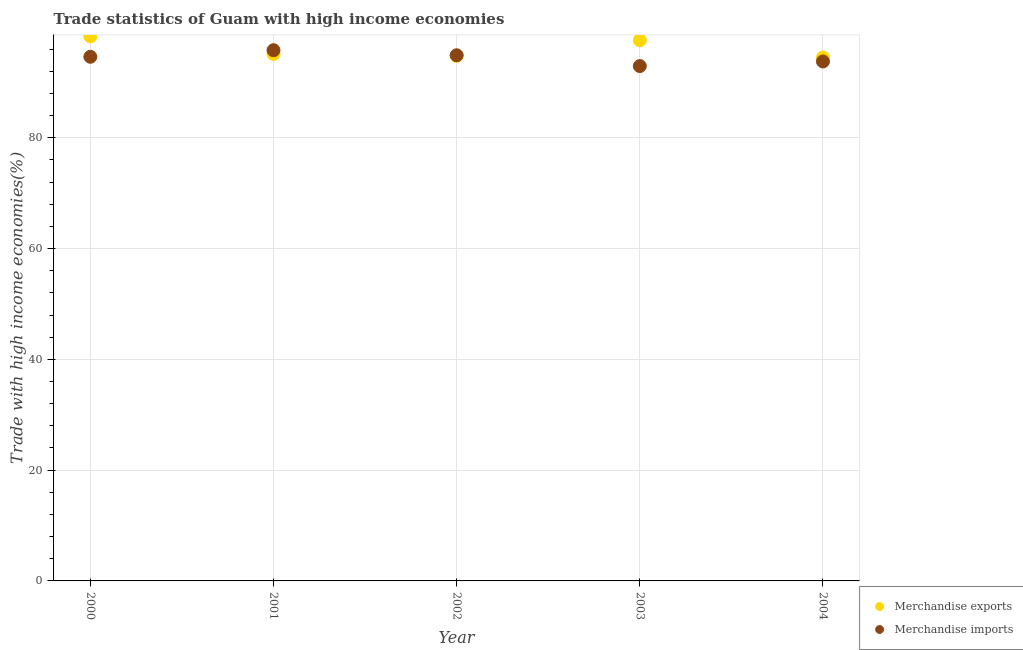How many different coloured dotlines are there?
Keep it short and to the point. 2. What is the merchandise imports in 2002?
Your response must be concise. 94.9. Across all years, what is the maximum merchandise imports?
Offer a terse response. 95.81. Across all years, what is the minimum merchandise exports?
Provide a succinct answer. 94.47. In which year was the merchandise exports maximum?
Offer a terse response. 2000. What is the total merchandise imports in the graph?
Your response must be concise. 472.04. What is the difference between the merchandise exports in 2000 and that in 2002?
Offer a terse response. 3.52. What is the difference between the merchandise exports in 2003 and the merchandise imports in 2001?
Give a very brief answer. 1.79. What is the average merchandise imports per year?
Provide a short and direct response. 94.41. In the year 2000, what is the difference between the merchandise imports and merchandise exports?
Offer a very short reply. -3.69. What is the ratio of the merchandise imports in 2000 to that in 2003?
Your response must be concise. 1.02. Is the merchandise imports in 2002 less than that in 2004?
Offer a terse response. No. Is the difference between the merchandise imports in 2002 and 2003 greater than the difference between the merchandise exports in 2002 and 2003?
Make the answer very short. Yes. What is the difference between the highest and the second highest merchandise imports?
Provide a succinct answer. 0.91. What is the difference between the highest and the lowest merchandise imports?
Provide a short and direct response. 2.86. In how many years, is the merchandise imports greater than the average merchandise imports taken over all years?
Keep it short and to the point. 3. Is the sum of the merchandise exports in 2000 and 2003 greater than the maximum merchandise imports across all years?
Your answer should be compact. Yes. Does the merchandise exports monotonically increase over the years?
Keep it short and to the point. No. Is the merchandise imports strictly less than the merchandise exports over the years?
Offer a very short reply. No. How many dotlines are there?
Your response must be concise. 2. Does the graph contain any zero values?
Keep it short and to the point. No. Does the graph contain grids?
Provide a short and direct response. Yes. How are the legend labels stacked?
Provide a short and direct response. Vertical. What is the title of the graph?
Provide a short and direct response. Trade statistics of Guam with high income economies. Does "Primary education" appear as one of the legend labels in the graph?
Provide a succinct answer. No. What is the label or title of the X-axis?
Ensure brevity in your answer.  Year. What is the label or title of the Y-axis?
Offer a terse response. Trade with high income economies(%). What is the Trade with high income economies(%) of Merchandise exports in 2000?
Provide a succinct answer. 98.31. What is the Trade with high income economies(%) of Merchandise imports in 2000?
Keep it short and to the point. 94.62. What is the Trade with high income economies(%) of Merchandise exports in 2001?
Make the answer very short. 95.12. What is the Trade with high income economies(%) in Merchandise imports in 2001?
Make the answer very short. 95.81. What is the Trade with high income economies(%) of Merchandise exports in 2002?
Provide a short and direct response. 94.78. What is the Trade with high income economies(%) in Merchandise imports in 2002?
Offer a very short reply. 94.9. What is the Trade with high income economies(%) of Merchandise exports in 2003?
Provide a succinct answer. 97.6. What is the Trade with high income economies(%) of Merchandise imports in 2003?
Your answer should be very brief. 92.94. What is the Trade with high income economies(%) in Merchandise exports in 2004?
Provide a succinct answer. 94.47. What is the Trade with high income economies(%) in Merchandise imports in 2004?
Give a very brief answer. 93.77. Across all years, what is the maximum Trade with high income economies(%) of Merchandise exports?
Give a very brief answer. 98.31. Across all years, what is the maximum Trade with high income economies(%) in Merchandise imports?
Provide a short and direct response. 95.81. Across all years, what is the minimum Trade with high income economies(%) in Merchandise exports?
Your answer should be compact. 94.47. Across all years, what is the minimum Trade with high income economies(%) in Merchandise imports?
Provide a short and direct response. 92.94. What is the total Trade with high income economies(%) of Merchandise exports in the graph?
Make the answer very short. 480.29. What is the total Trade with high income economies(%) of Merchandise imports in the graph?
Your answer should be compact. 472.04. What is the difference between the Trade with high income economies(%) in Merchandise exports in 2000 and that in 2001?
Your response must be concise. 3.18. What is the difference between the Trade with high income economies(%) of Merchandise imports in 2000 and that in 2001?
Your response must be concise. -1.19. What is the difference between the Trade with high income economies(%) in Merchandise exports in 2000 and that in 2002?
Keep it short and to the point. 3.52. What is the difference between the Trade with high income economies(%) in Merchandise imports in 2000 and that in 2002?
Offer a terse response. -0.27. What is the difference between the Trade with high income economies(%) in Merchandise exports in 2000 and that in 2003?
Offer a very short reply. 0.71. What is the difference between the Trade with high income economies(%) of Merchandise imports in 2000 and that in 2003?
Keep it short and to the point. 1.68. What is the difference between the Trade with high income economies(%) of Merchandise exports in 2000 and that in 2004?
Your response must be concise. 3.84. What is the difference between the Trade with high income economies(%) in Merchandise imports in 2000 and that in 2004?
Make the answer very short. 0.85. What is the difference between the Trade with high income economies(%) in Merchandise exports in 2001 and that in 2002?
Give a very brief answer. 0.34. What is the difference between the Trade with high income economies(%) of Merchandise imports in 2001 and that in 2002?
Ensure brevity in your answer.  0.91. What is the difference between the Trade with high income economies(%) in Merchandise exports in 2001 and that in 2003?
Ensure brevity in your answer.  -2.48. What is the difference between the Trade with high income economies(%) of Merchandise imports in 2001 and that in 2003?
Provide a succinct answer. 2.86. What is the difference between the Trade with high income economies(%) in Merchandise exports in 2001 and that in 2004?
Offer a very short reply. 0.65. What is the difference between the Trade with high income economies(%) in Merchandise imports in 2001 and that in 2004?
Give a very brief answer. 2.04. What is the difference between the Trade with high income economies(%) in Merchandise exports in 2002 and that in 2003?
Your answer should be very brief. -2.82. What is the difference between the Trade with high income economies(%) of Merchandise imports in 2002 and that in 2003?
Provide a short and direct response. 1.95. What is the difference between the Trade with high income economies(%) in Merchandise exports in 2002 and that in 2004?
Your answer should be compact. 0.31. What is the difference between the Trade with high income economies(%) in Merchandise imports in 2002 and that in 2004?
Keep it short and to the point. 1.13. What is the difference between the Trade with high income economies(%) in Merchandise exports in 2003 and that in 2004?
Provide a short and direct response. 3.13. What is the difference between the Trade with high income economies(%) of Merchandise imports in 2003 and that in 2004?
Offer a terse response. -0.83. What is the difference between the Trade with high income economies(%) in Merchandise exports in 2000 and the Trade with high income economies(%) in Merchandise imports in 2001?
Ensure brevity in your answer.  2.5. What is the difference between the Trade with high income economies(%) in Merchandise exports in 2000 and the Trade with high income economies(%) in Merchandise imports in 2002?
Your answer should be compact. 3.41. What is the difference between the Trade with high income economies(%) in Merchandise exports in 2000 and the Trade with high income economies(%) in Merchandise imports in 2003?
Give a very brief answer. 5.36. What is the difference between the Trade with high income economies(%) of Merchandise exports in 2000 and the Trade with high income economies(%) of Merchandise imports in 2004?
Ensure brevity in your answer.  4.54. What is the difference between the Trade with high income economies(%) of Merchandise exports in 2001 and the Trade with high income economies(%) of Merchandise imports in 2002?
Give a very brief answer. 0.23. What is the difference between the Trade with high income economies(%) in Merchandise exports in 2001 and the Trade with high income economies(%) in Merchandise imports in 2003?
Provide a short and direct response. 2.18. What is the difference between the Trade with high income economies(%) of Merchandise exports in 2001 and the Trade with high income economies(%) of Merchandise imports in 2004?
Your response must be concise. 1.35. What is the difference between the Trade with high income economies(%) in Merchandise exports in 2002 and the Trade with high income economies(%) in Merchandise imports in 2003?
Your response must be concise. 1.84. What is the difference between the Trade with high income economies(%) in Merchandise exports in 2002 and the Trade with high income economies(%) in Merchandise imports in 2004?
Offer a very short reply. 1.01. What is the difference between the Trade with high income economies(%) of Merchandise exports in 2003 and the Trade with high income economies(%) of Merchandise imports in 2004?
Your response must be concise. 3.83. What is the average Trade with high income economies(%) of Merchandise exports per year?
Ensure brevity in your answer.  96.06. What is the average Trade with high income economies(%) in Merchandise imports per year?
Give a very brief answer. 94.41. In the year 2000, what is the difference between the Trade with high income economies(%) in Merchandise exports and Trade with high income economies(%) in Merchandise imports?
Provide a succinct answer. 3.69. In the year 2001, what is the difference between the Trade with high income economies(%) of Merchandise exports and Trade with high income economies(%) of Merchandise imports?
Your answer should be compact. -0.68. In the year 2002, what is the difference between the Trade with high income economies(%) of Merchandise exports and Trade with high income economies(%) of Merchandise imports?
Your response must be concise. -0.11. In the year 2003, what is the difference between the Trade with high income economies(%) in Merchandise exports and Trade with high income economies(%) in Merchandise imports?
Provide a short and direct response. 4.66. In the year 2004, what is the difference between the Trade with high income economies(%) of Merchandise exports and Trade with high income economies(%) of Merchandise imports?
Offer a terse response. 0.7. What is the ratio of the Trade with high income economies(%) in Merchandise exports in 2000 to that in 2001?
Provide a short and direct response. 1.03. What is the ratio of the Trade with high income economies(%) in Merchandise imports in 2000 to that in 2001?
Make the answer very short. 0.99. What is the ratio of the Trade with high income economies(%) in Merchandise exports in 2000 to that in 2002?
Provide a short and direct response. 1.04. What is the ratio of the Trade with high income economies(%) of Merchandise exports in 2000 to that in 2003?
Keep it short and to the point. 1.01. What is the ratio of the Trade with high income economies(%) in Merchandise imports in 2000 to that in 2003?
Provide a short and direct response. 1.02. What is the ratio of the Trade with high income economies(%) of Merchandise exports in 2000 to that in 2004?
Your answer should be compact. 1.04. What is the ratio of the Trade with high income economies(%) in Merchandise imports in 2000 to that in 2004?
Keep it short and to the point. 1.01. What is the ratio of the Trade with high income economies(%) in Merchandise exports in 2001 to that in 2002?
Make the answer very short. 1. What is the ratio of the Trade with high income economies(%) in Merchandise imports in 2001 to that in 2002?
Give a very brief answer. 1.01. What is the ratio of the Trade with high income economies(%) in Merchandise exports in 2001 to that in 2003?
Make the answer very short. 0.97. What is the ratio of the Trade with high income economies(%) of Merchandise imports in 2001 to that in 2003?
Keep it short and to the point. 1.03. What is the ratio of the Trade with high income economies(%) of Merchandise exports in 2001 to that in 2004?
Offer a very short reply. 1.01. What is the ratio of the Trade with high income economies(%) of Merchandise imports in 2001 to that in 2004?
Offer a terse response. 1.02. What is the ratio of the Trade with high income economies(%) of Merchandise exports in 2002 to that in 2003?
Ensure brevity in your answer.  0.97. What is the ratio of the Trade with high income economies(%) of Merchandise imports in 2002 to that in 2003?
Your answer should be very brief. 1.02. What is the ratio of the Trade with high income economies(%) of Merchandise imports in 2002 to that in 2004?
Your answer should be very brief. 1.01. What is the ratio of the Trade with high income economies(%) of Merchandise exports in 2003 to that in 2004?
Provide a short and direct response. 1.03. What is the ratio of the Trade with high income economies(%) of Merchandise imports in 2003 to that in 2004?
Ensure brevity in your answer.  0.99. What is the difference between the highest and the second highest Trade with high income economies(%) in Merchandise exports?
Make the answer very short. 0.71. What is the difference between the highest and the second highest Trade with high income economies(%) in Merchandise imports?
Provide a short and direct response. 0.91. What is the difference between the highest and the lowest Trade with high income economies(%) in Merchandise exports?
Offer a terse response. 3.84. What is the difference between the highest and the lowest Trade with high income economies(%) of Merchandise imports?
Make the answer very short. 2.86. 